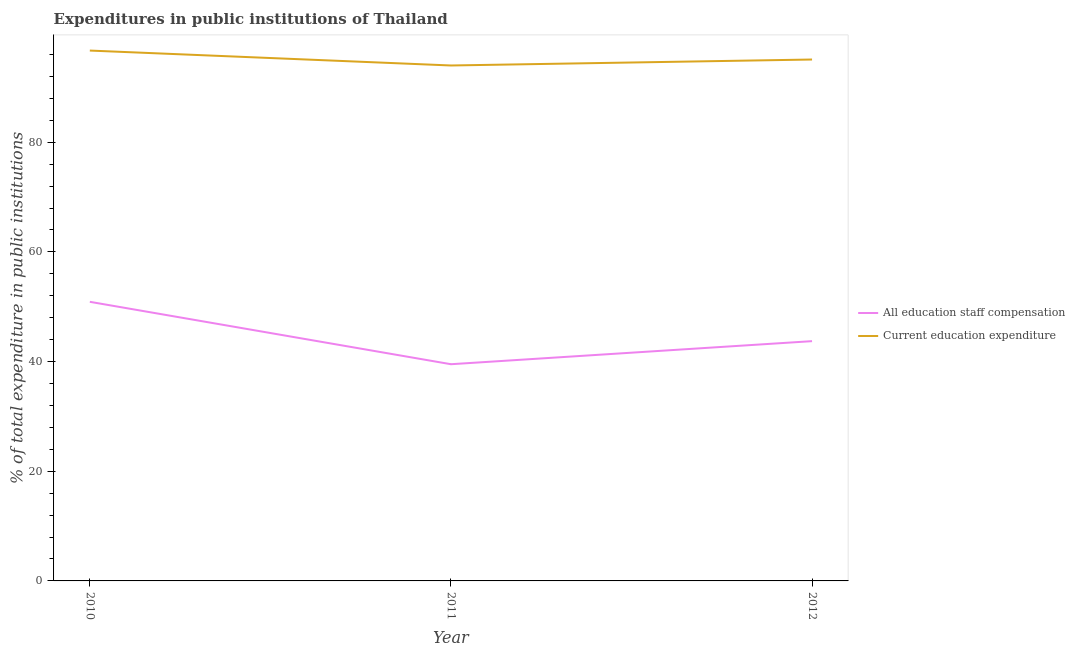How many different coloured lines are there?
Make the answer very short. 2. Does the line corresponding to expenditure in education intersect with the line corresponding to expenditure in staff compensation?
Your answer should be compact. No. Is the number of lines equal to the number of legend labels?
Provide a short and direct response. Yes. What is the expenditure in staff compensation in 2012?
Ensure brevity in your answer.  43.73. Across all years, what is the maximum expenditure in education?
Make the answer very short. 96.72. Across all years, what is the minimum expenditure in staff compensation?
Offer a very short reply. 39.52. In which year was the expenditure in staff compensation maximum?
Your answer should be very brief. 2010. What is the total expenditure in staff compensation in the graph?
Your response must be concise. 134.15. What is the difference between the expenditure in education in 2010 and that in 2012?
Your answer should be very brief. 1.63. What is the difference between the expenditure in staff compensation in 2010 and the expenditure in education in 2011?
Offer a very short reply. -43.1. What is the average expenditure in staff compensation per year?
Your answer should be very brief. 44.72. In the year 2012, what is the difference between the expenditure in education and expenditure in staff compensation?
Offer a very short reply. 51.36. In how many years, is the expenditure in staff compensation greater than 4 %?
Make the answer very short. 3. What is the ratio of the expenditure in education in 2010 to that in 2012?
Offer a terse response. 1.02. What is the difference between the highest and the second highest expenditure in education?
Give a very brief answer. 1.63. What is the difference between the highest and the lowest expenditure in education?
Make the answer very short. 2.72. Is the sum of the expenditure in education in 2011 and 2012 greater than the maximum expenditure in staff compensation across all years?
Offer a terse response. Yes. Does the expenditure in staff compensation monotonically increase over the years?
Ensure brevity in your answer.  No. Is the expenditure in education strictly greater than the expenditure in staff compensation over the years?
Provide a succinct answer. Yes. Does the graph contain any zero values?
Give a very brief answer. No. How many legend labels are there?
Your response must be concise. 2. How are the legend labels stacked?
Give a very brief answer. Vertical. What is the title of the graph?
Your answer should be very brief. Expenditures in public institutions of Thailand. What is the label or title of the Y-axis?
Your answer should be compact. % of total expenditure in public institutions. What is the % of total expenditure in public institutions in All education staff compensation in 2010?
Offer a very short reply. 50.9. What is the % of total expenditure in public institutions in Current education expenditure in 2010?
Offer a very short reply. 96.72. What is the % of total expenditure in public institutions in All education staff compensation in 2011?
Give a very brief answer. 39.52. What is the % of total expenditure in public institutions in Current education expenditure in 2011?
Offer a terse response. 94. What is the % of total expenditure in public institutions of All education staff compensation in 2012?
Provide a succinct answer. 43.73. What is the % of total expenditure in public institutions in Current education expenditure in 2012?
Your answer should be compact. 95.09. Across all years, what is the maximum % of total expenditure in public institutions of All education staff compensation?
Offer a very short reply. 50.9. Across all years, what is the maximum % of total expenditure in public institutions of Current education expenditure?
Offer a terse response. 96.72. Across all years, what is the minimum % of total expenditure in public institutions of All education staff compensation?
Make the answer very short. 39.52. Across all years, what is the minimum % of total expenditure in public institutions of Current education expenditure?
Offer a very short reply. 94. What is the total % of total expenditure in public institutions of All education staff compensation in the graph?
Your answer should be compact. 134.15. What is the total % of total expenditure in public institutions of Current education expenditure in the graph?
Ensure brevity in your answer.  285.81. What is the difference between the % of total expenditure in public institutions in All education staff compensation in 2010 and that in 2011?
Your response must be concise. 11.38. What is the difference between the % of total expenditure in public institutions in Current education expenditure in 2010 and that in 2011?
Your response must be concise. 2.72. What is the difference between the % of total expenditure in public institutions in All education staff compensation in 2010 and that in 2012?
Your answer should be very brief. 7.17. What is the difference between the % of total expenditure in public institutions of Current education expenditure in 2010 and that in 2012?
Provide a short and direct response. 1.63. What is the difference between the % of total expenditure in public institutions of All education staff compensation in 2011 and that in 2012?
Give a very brief answer. -4.21. What is the difference between the % of total expenditure in public institutions of Current education expenditure in 2011 and that in 2012?
Your response must be concise. -1.09. What is the difference between the % of total expenditure in public institutions in All education staff compensation in 2010 and the % of total expenditure in public institutions in Current education expenditure in 2011?
Provide a short and direct response. -43.1. What is the difference between the % of total expenditure in public institutions in All education staff compensation in 2010 and the % of total expenditure in public institutions in Current education expenditure in 2012?
Your answer should be very brief. -44.19. What is the difference between the % of total expenditure in public institutions in All education staff compensation in 2011 and the % of total expenditure in public institutions in Current education expenditure in 2012?
Your answer should be compact. -55.57. What is the average % of total expenditure in public institutions of All education staff compensation per year?
Make the answer very short. 44.72. What is the average % of total expenditure in public institutions of Current education expenditure per year?
Provide a short and direct response. 95.27. In the year 2010, what is the difference between the % of total expenditure in public institutions of All education staff compensation and % of total expenditure in public institutions of Current education expenditure?
Offer a very short reply. -45.82. In the year 2011, what is the difference between the % of total expenditure in public institutions of All education staff compensation and % of total expenditure in public institutions of Current education expenditure?
Make the answer very short. -54.48. In the year 2012, what is the difference between the % of total expenditure in public institutions of All education staff compensation and % of total expenditure in public institutions of Current education expenditure?
Offer a terse response. -51.36. What is the ratio of the % of total expenditure in public institutions in All education staff compensation in 2010 to that in 2011?
Ensure brevity in your answer.  1.29. What is the ratio of the % of total expenditure in public institutions in Current education expenditure in 2010 to that in 2011?
Keep it short and to the point. 1.03. What is the ratio of the % of total expenditure in public institutions in All education staff compensation in 2010 to that in 2012?
Your response must be concise. 1.16. What is the ratio of the % of total expenditure in public institutions in Current education expenditure in 2010 to that in 2012?
Keep it short and to the point. 1.02. What is the ratio of the % of total expenditure in public institutions of All education staff compensation in 2011 to that in 2012?
Your response must be concise. 0.9. What is the ratio of the % of total expenditure in public institutions of Current education expenditure in 2011 to that in 2012?
Keep it short and to the point. 0.99. What is the difference between the highest and the second highest % of total expenditure in public institutions in All education staff compensation?
Your response must be concise. 7.17. What is the difference between the highest and the second highest % of total expenditure in public institutions in Current education expenditure?
Provide a succinct answer. 1.63. What is the difference between the highest and the lowest % of total expenditure in public institutions of All education staff compensation?
Make the answer very short. 11.38. What is the difference between the highest and the lowest % of total expenditure in public institutions of Current education expenditure?
Provide a short and direct response. 2.72. 